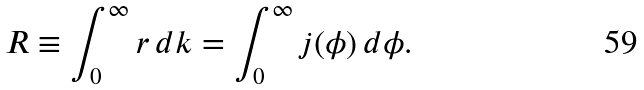Convert formula to latex. <formula><loc_0><loc_0><loc_500><loc_500>R \equiv \int _ { 0 } ^ { \infty } r \, d k = \int _ { 0 } ^ { \infty } j ( \phi ) \, d \phi .</formula> 